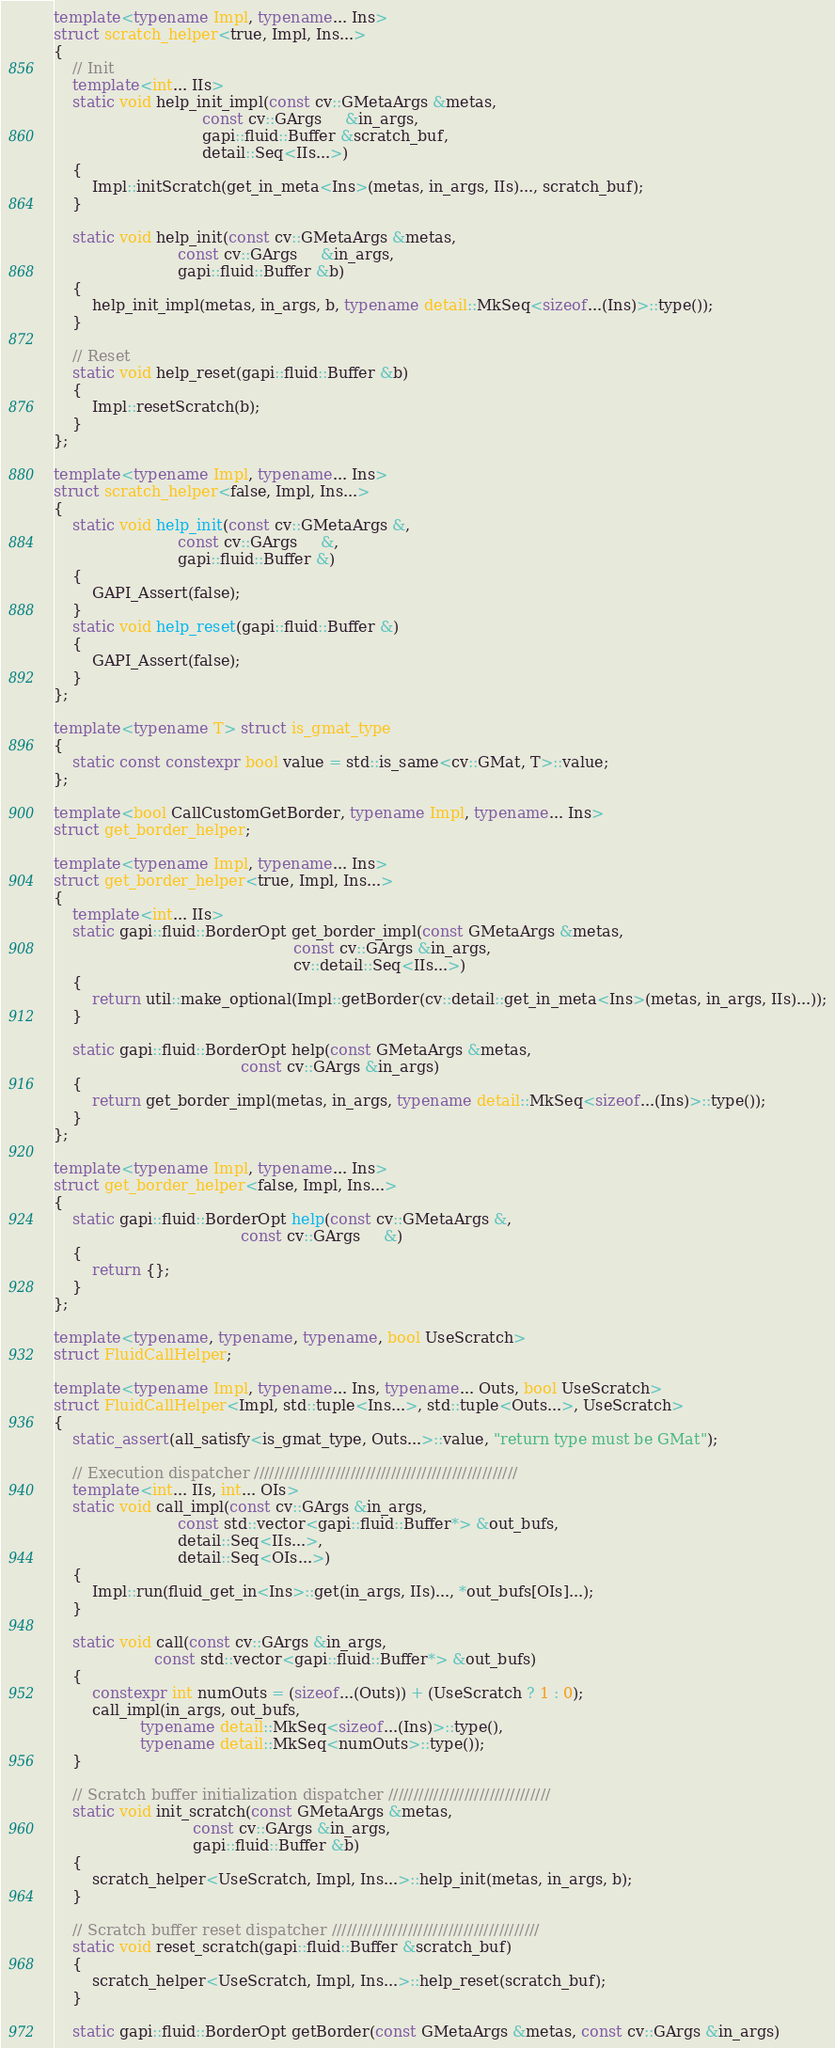<code> <loc_0><loc_0><loc_500><loc_500><_C++_>template<typename Impl, typename... Ins>
struct scratch_helper<true, Impl, Ins...>
{
    // Init
    template<int... IIs>
    static void help_init_impl(const cv::GMetaArgs &metas,
                               const cv::GArgs     &in_args,
                               gapi::fluid::Buffer &scratch_buf,
                               detail::Seq<IIs...>)
    {
        Impl::initScratch(get_in_meta<Ins>(metas, in_args, IIs)..., scratch_buf);
    }

    static void help_init(const cv::GMetaArgs &metas,
                          const cv::GArgs     &in_args,
                          gapi::fluid::Buffer &b)
    {
        help_init_impl(metas, in_args, b, typename detail::MkSeq<sizeof...(Ins)>::type());
    }

    // Reset
    static void help_reset(gapi::fluid::Buffer &b)
    {
        Impl::resetScratch(b);
    }
};

template<typename Impl, typename... Ins>
struct scratch_helper<false, Impl, Ins...>
{
    static void help_init(const cv::GMetaArgs &,
                          const cv::GArgs     &,
                          gapi::fluid::Buffer &)
    {
        GAPI_Assert(false);
    }
    static void help_reset(gapi::fluid::Buffer &)
    {
        GAPI_Assert(false);
    }
};

template<typename T> struct is_gmat_type
{
    static const constexpr bool value = std::is_same<cv::GMat, T>::value;
};

template<bool CallCustomGetBorder, typename Impl, typename... Ins>
struct get_border_helper;

template<typename Impl, typename... Ins>
struct get_border_helper<true, Impl, Ins...>
{
    template<int... IIs>
    static gapi::fluid::BorderOpt get_border_impl(const GMetaArgs &metas,
                                                  const cv::GArgs &in_args,
                                                  cv::detail::Seq<IIs...>)
    {
        return util::make_optional(Impl::getBorder(cv::detail::get_in_meta<Ins>(metas, in_args, IIs)...));
    }

    static gapi::fluid::BorderOpt help(const GMetaArgs &metas,
                                       const cv::GArgs &in_args)
    {
        return get_border_impl(metas, in_args, typename detail::MkSeq<sizeof...(Ins)>::type());
    }
};

template<typename Impl, typename... Ins>
struct get_border_helper<false, Impl, Ins...>
{
    static gapi::fluid::BorderOpt help(const cv::GMetaArgs &,
                                       const cv::GArgs     &)
    {
        return {};
    }
};

template<typename, typename, typename, bool UseScratch>
struct FluidCallHelper;

template<typename Impl, typename... Ins, typename... Outs, bool UseScratch>
struct FluidCallHelper<Impl, std::tuple<Ins...>, std::tuple<Outs...>, UseScratch>
{
    static_assert(all_satisfy<is_gmat_type, Outs...>::value, "return type must be GMat");

    // Execution dispatcher ////////////////////////////////////////////////////
    template<int... IIs, int... OIs>
    static void call_impl(const cv::GArgs &in_args,
                          const std::vector<gapi::fluid::Buffer*> &out_bufs,
                          detail::Seq<IIs...>,
                          detail::Seq<OIs...>)
    {
        Impl::run(fluid_get_in<Ins>::get(in_args, IIs)..., *out_bufs[OIs]...);
    }

    static void call(const cv::GArgs &in_args,
                     const std::vector<gapi::fluid::Buffer*> &out_bufs)
    {
        constexpr int numOuts = (sizeof...(Outs)) + (UseScratch ? 1 : 0);
        call_impl(in_args, out_bufs,
                  typename detail::MkSeq<sizeof...(Ins)>::type(),
                  typename detail::MkSeq<numOuts>::type());
    }

    // Scratch buffer initialization dispatcher ////////////////////////////////
    static void init_scratch(const GMetaArgs &metas,
                             const cv::GArgs &in_args,
                             gapi::fluid::Buffer &b)
    {
        scratch_helper<UseScratch, Impl, Ins...>::help_init(metas, in_args, b);
    }

    // Scratch buffer reset dispatcher /////////////////////////////////////////
    static void reset_scratch(gapi::fluid::Buffer &scratch_buf)
    {
        scratch_helper<UseScratch, Impl, Ins...>::help_reset(scratch_buf);
    }

    static gapi::fluid::BorderOpt getBorder(const GMetaArgs &metas, const cv::GArgs &in_args)</code> 